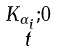Convert formula to latex. <formula><loc_0><loc_0><loc_500><loc_500>\begin{smallmatrix} K _ { \alpha _ { i } } ; 0 \\ t \end{smallmatrix}</formula> 